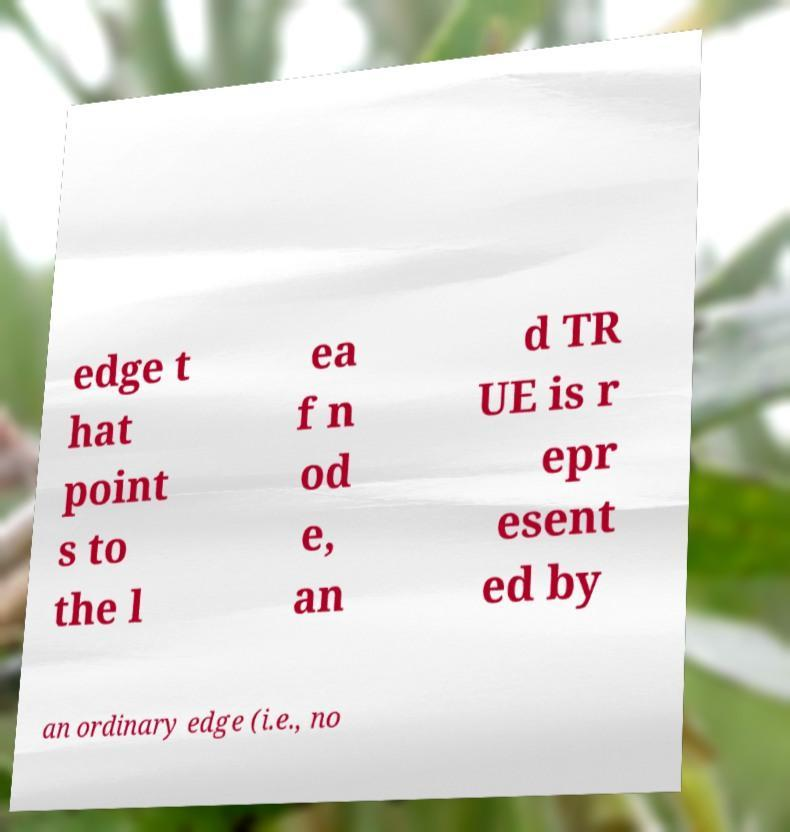Can you accurately transcribe the text from the provided image for me? edge t hat point s to the l ea f n od e, an d TR UE is r epr esent ed by an ordinary edge (i.e., no 